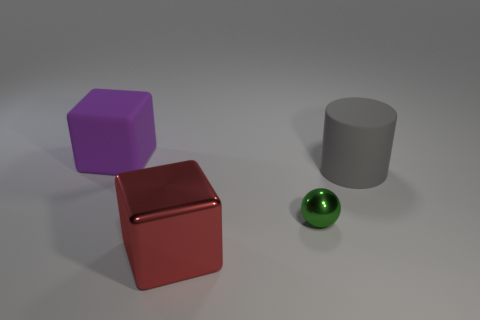Is there any other thing that is the same size as the sphere?
Your answer should be very brief. No. Is there a big thing left of the cube in front of the ball?
Ensure brevity in your answer.  Yes. How many other things are the same shape as the large metal thing?
Offer a terse response. 1. Are there more metal spheres that are behind the small green metallic thing than big matte cylinders that are behind the large gray rubber cylinder?
Provide a succinct answer. No. There is a cube on the right side of the rubber block; is it the same size as the cube to the left of the large red shiny block?
Your response must be concise. Yes. The tiny green object is what shape?
Provide a short and direct response. Sphere. The large cube that is the same material as the tiny green ball is what color?
Your answer should be compact. Red. Do the ball and the object that is in front of the tiny thing have the same material?
Your response must be concise. Yes. What color is the metallic cube?
Offer a very short reply. Red. The cylinder that is the same material as the purple cube is what size?
Ensure brevity in your answer.  Large. 